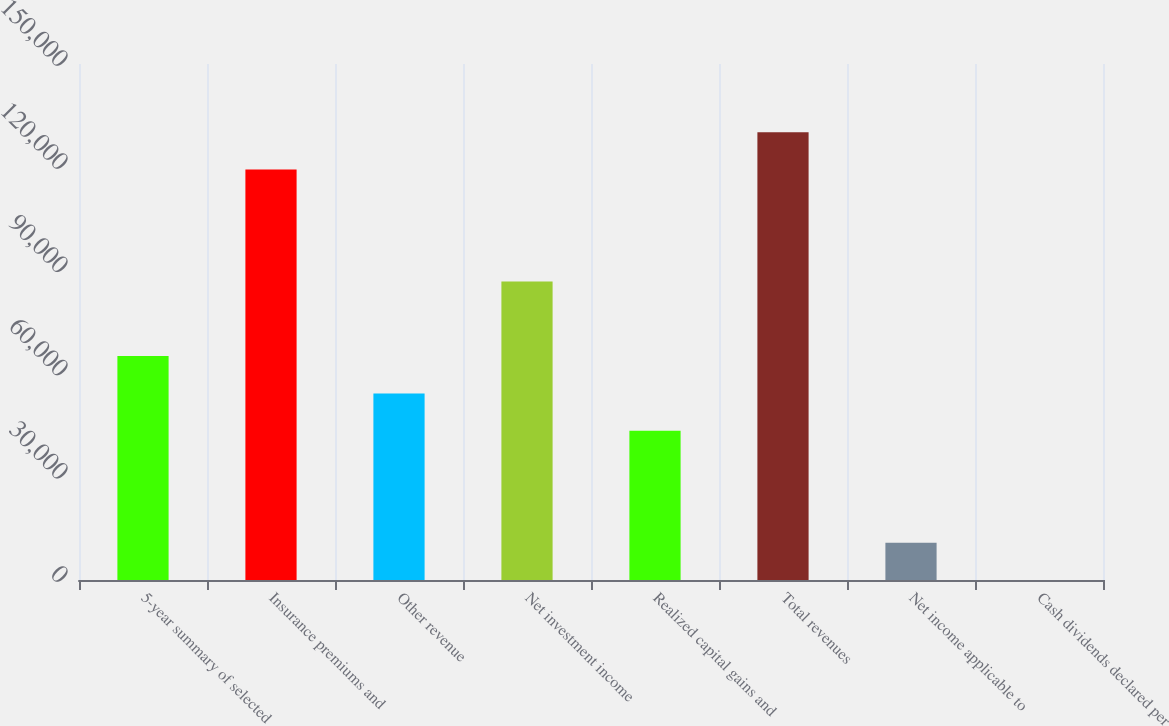<chart> <loc_0><loc_0><loc_500><loc_500><bar_chart><fcel>5-year summary of selected<fcel>Insurance premiums and<fcel>Other revenue<fcel>Net investment income<fcel>Realized capital gains and<fcel>Total revenues<fcel>Net income applicable to<fcel>Cash dividends declared per<nl><fcel>65087.9<fcel>119327<fcel>54240.1<fcel>86783.4<fcel>43392.3<fcel>130175<fcel>10848.9<fcel>1.12<nl></chart> 